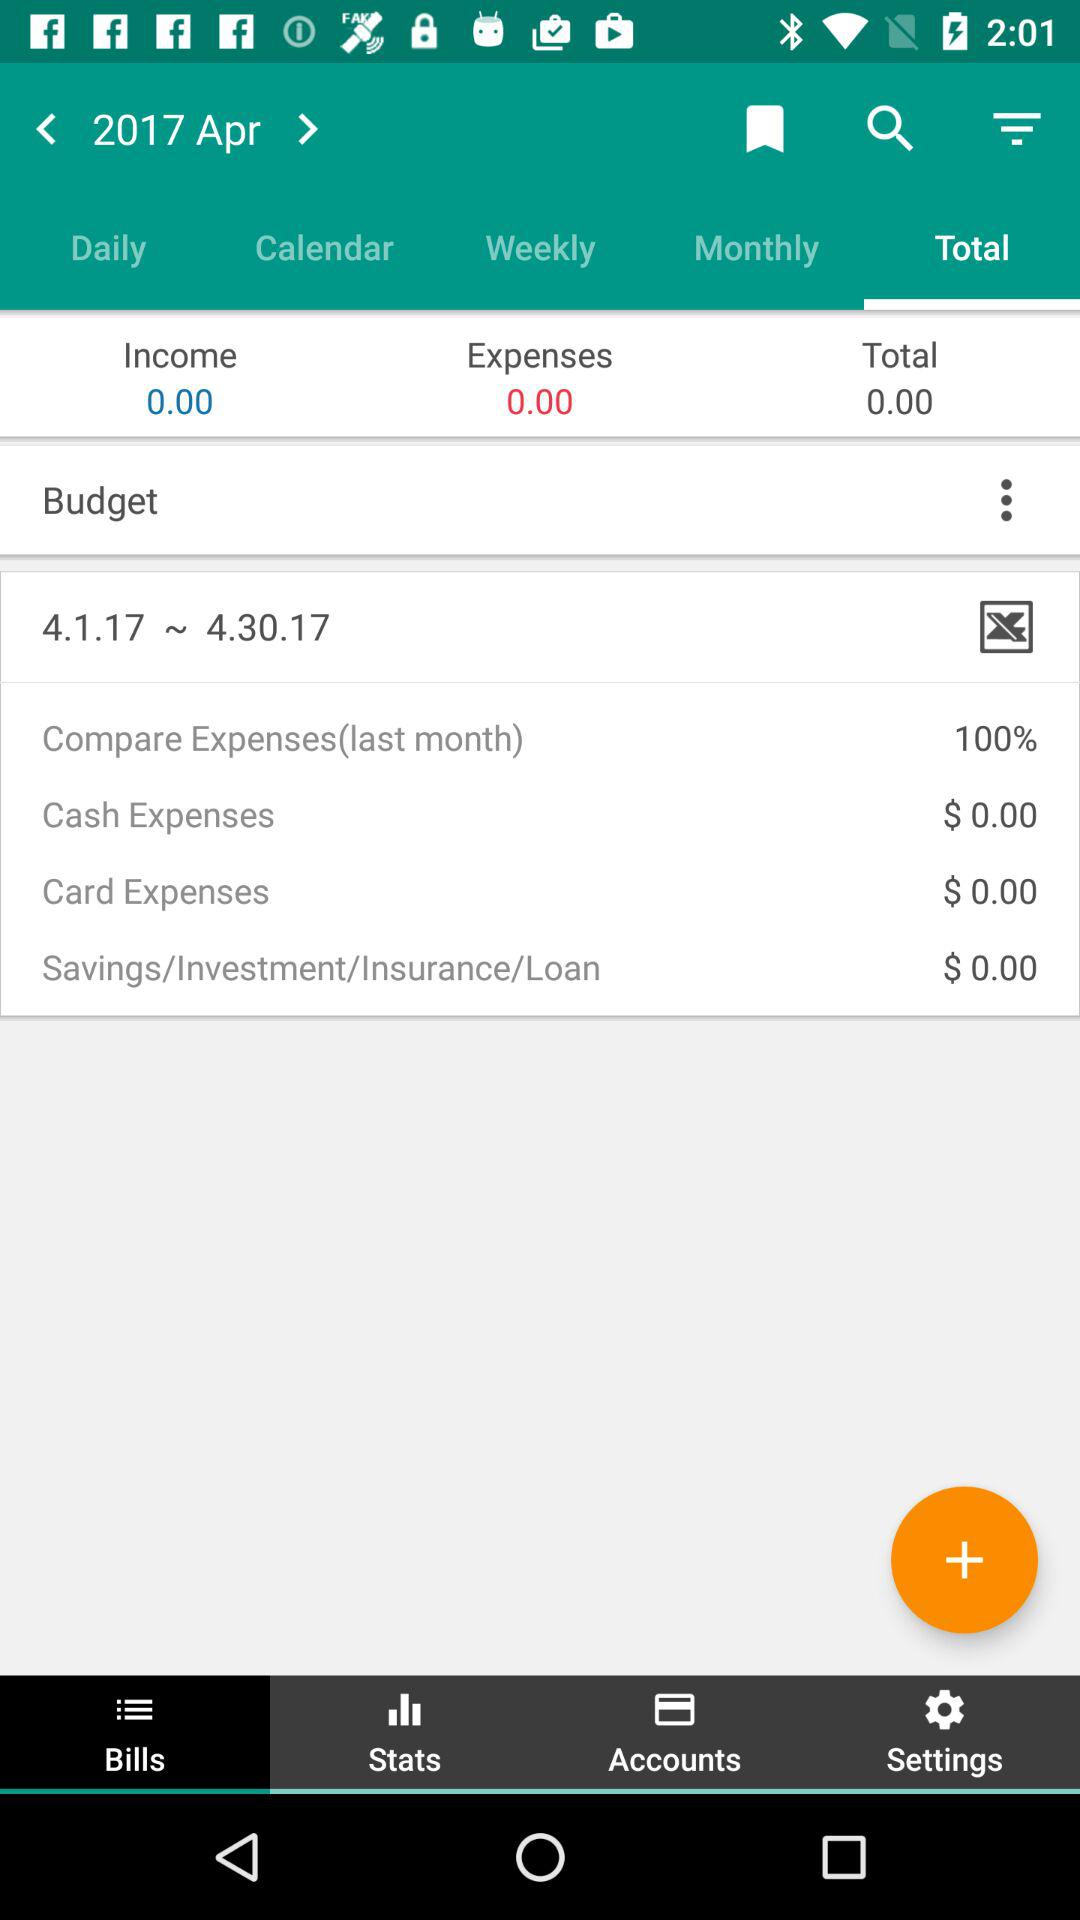How much is the total amount of cash expenses?
Answer the question using a single word or phrase. $ 0.00 